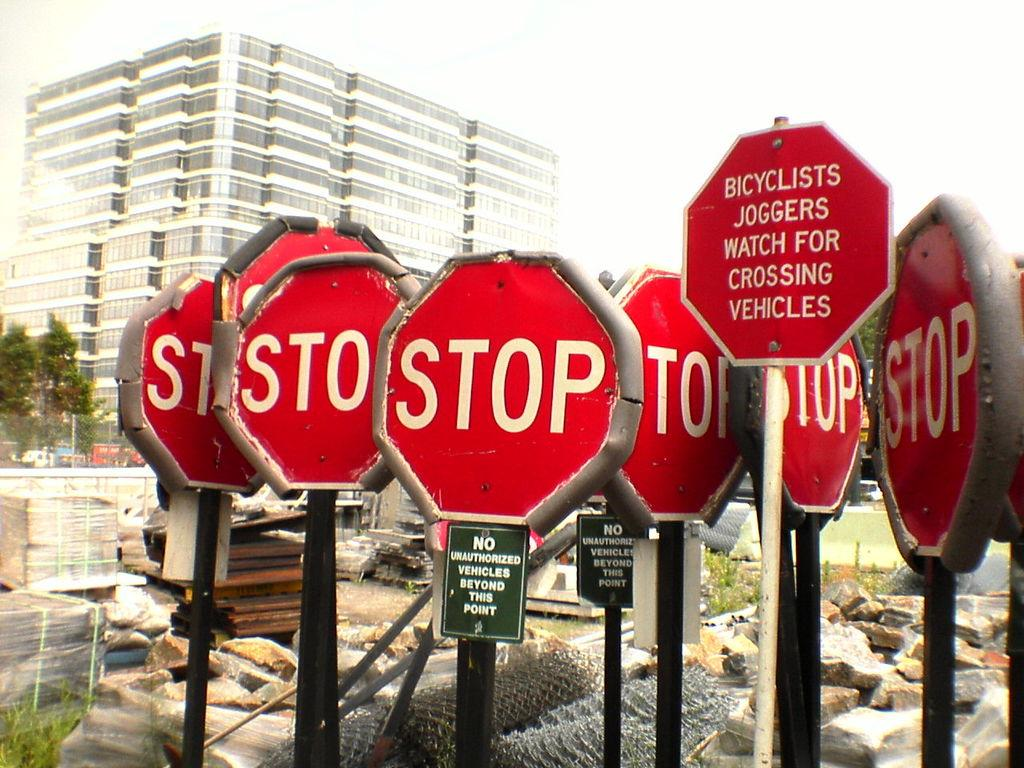<image>
Describe the image concisely. Several red STOP signs infront of a large building 